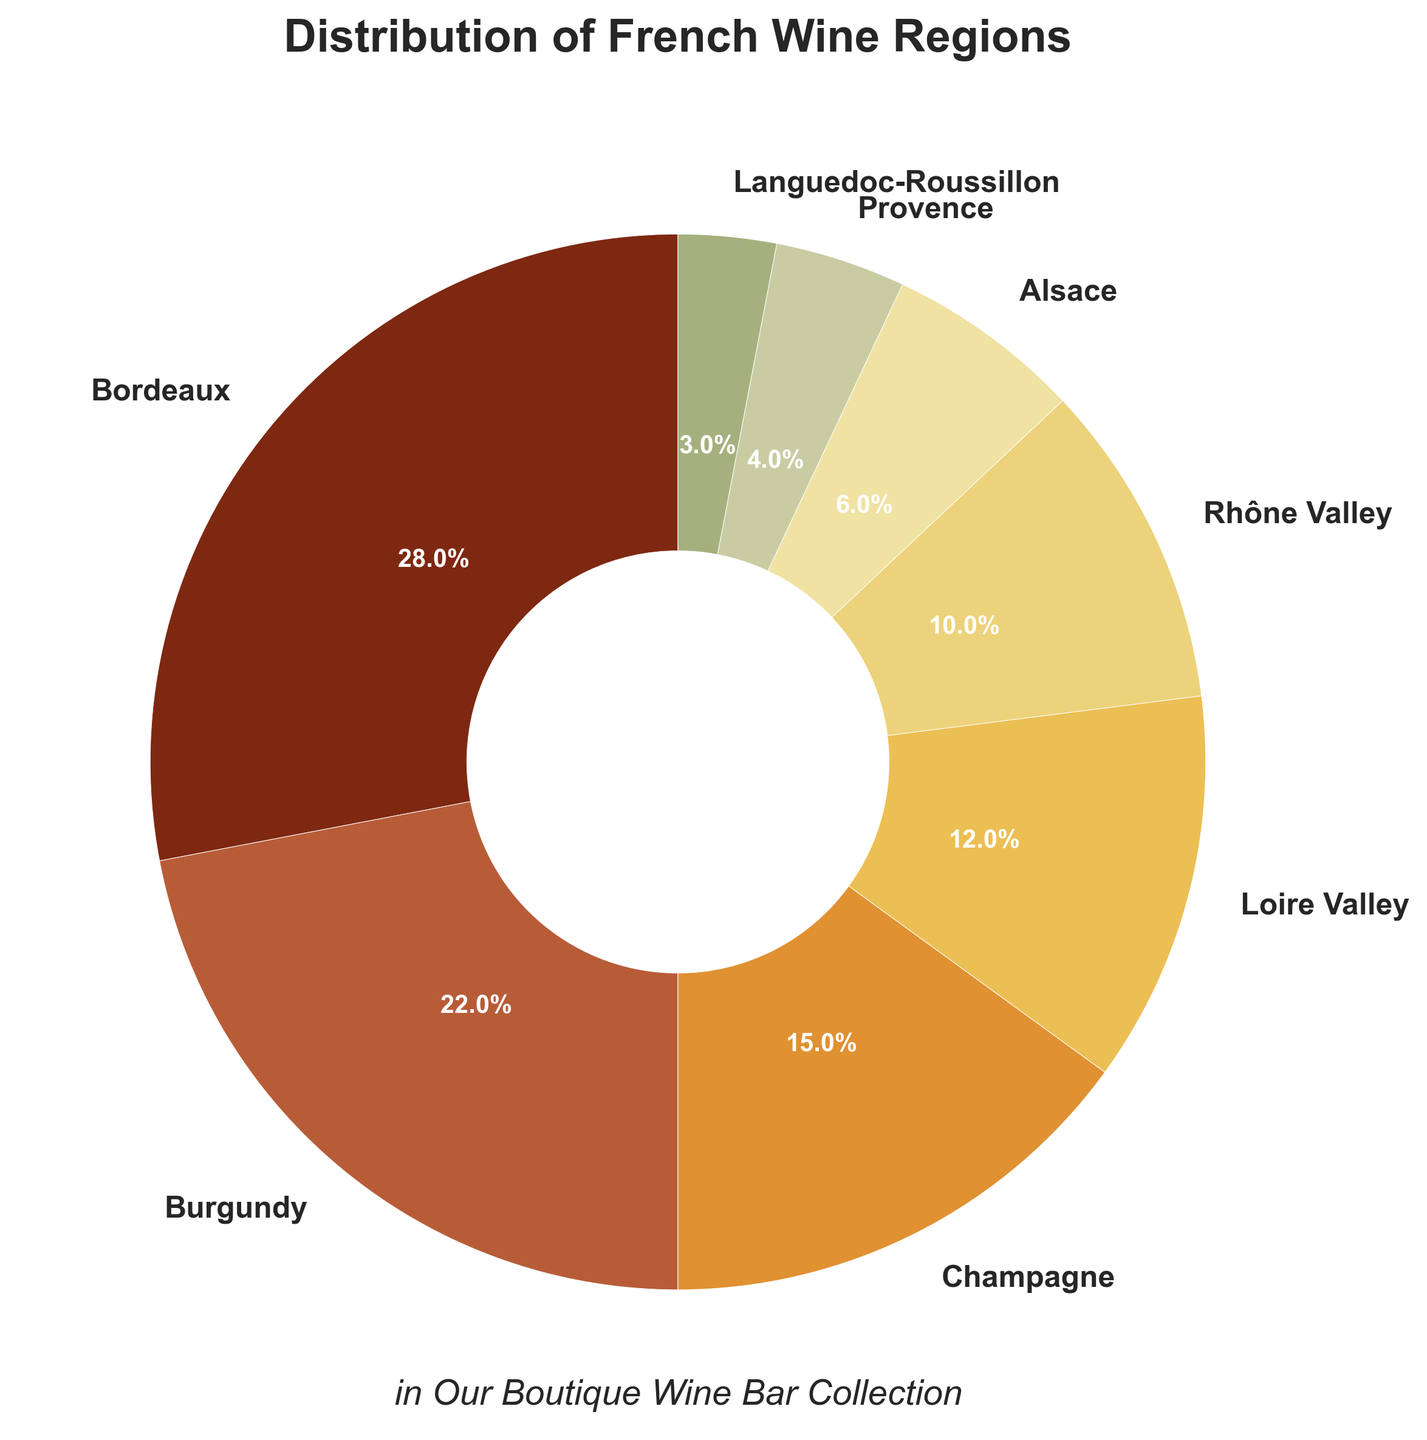Which region has the highest representation in the wine bar collection? By looking at the pie chart, identify the region with the largest slice. In this case, it's the region taking up 28%, which is the Bordeaux slice.
Answer: Bordeaux Which two regions combined account for the highest representation in the collection? Identify the two largest slices in the pie chart, which are Bordeaux (28%) and Burgundy (22%). Add their percentages together (28% + 22% = 50%).
Answer: Bordeaux and Burgundy Which region has a smaller representation, Provence or Alsace? Locate the Provence and Alsace slices in the pie chart and compare their sizes. Provence is 4% and Alsace is 6%, so Provence is smaller.
Answer: Provence How much more representation does Champagne have compared to Languedoc-Roussillon? Subtract the percentage of Languedoc-Roussillon from Champagne's percentage (15% - 3% = 12%).
Answer: 12% What total percentage of the collection comes from regions with less than 10% representation each? Add the percentages of all regions with less than 10% representation: Alsace (6%) + Provence (4%) + Languedoc-Roussillon (3%) = 6% + 4% + 3% = 13%.
Answer: 13% Is the representation of Champagne greater than the combined representation of Provence and Languedoc-Roussillon? Compare the percentage of Champagne (15%) with the sum of Provence and Languedoc-Roussillon (4% + 3% = 7%). Champagne's representation is greater (15% > 7%).
Answer: Yes What is the average percentage representation of Burgundy, Loire Valley, and Rhône Valley? Sum the percentages of Burgundy, Loire Valley, and Rhône Valley: 22% + 12% + 10% = 44%. Then divide by the number of regions: 44% / 3 ≈ 14.67%.
Answer: 14.67% Which region has the lightest color on the pie chart? Look for the slice with the lightest shade. The lightest color represents Languedoc-Roussillon.
Answer: Languedoc-Roussillon 